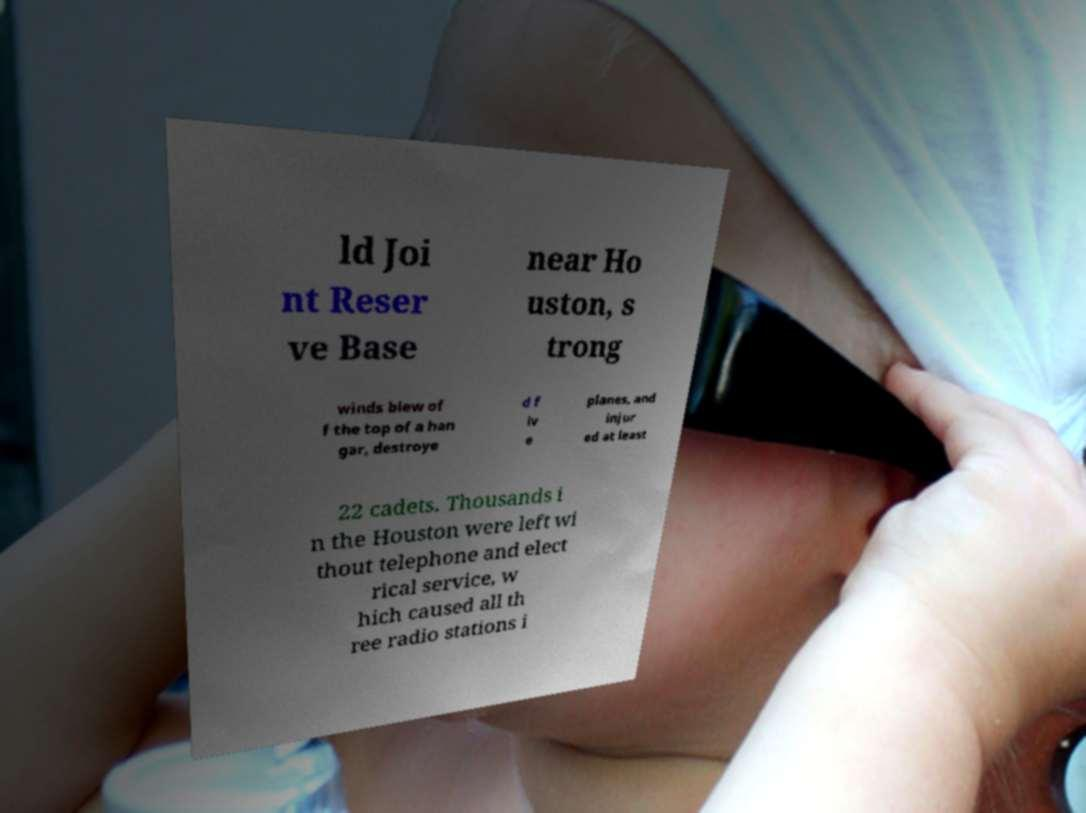For documentation purposes, I need the text within this image transcribed. Could you provide that? ld Joi nt Reser ve Base near Ho uston, s trong winds blew of f the top of a han gar, destroye d f iv e planes, and injur ed at least 22 cadets. Thousands i n the Houston were left wi thout telephone and elect rical service, w hich caused all th ree radio stations i 